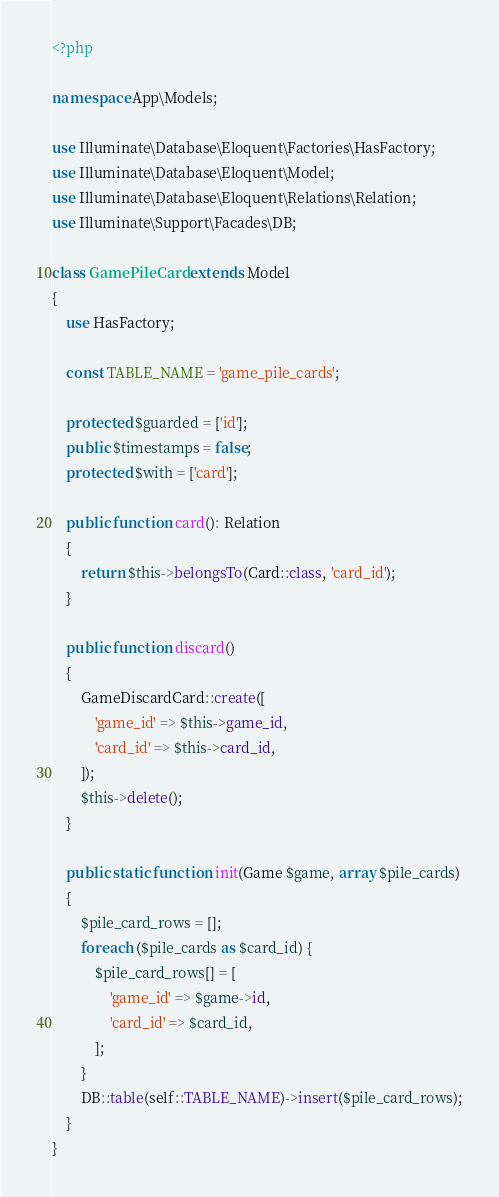Convert code to text. <code><loc_0><loc_0><loc_500><loc_500><_PHP_><?php

namespace App\Models;

use Illuminate\Database\Eloquent\Factories\HasFactory;
use Illuminate\Database\Eloquent\Model;
use Illuminate\Database\Eloquent\Relations\Relation;
use Illuminate\Support\Facades\DB;

class GamePileCard extends Model
{
    use HasFactory;

    const TABLE_NAME = 'game_pile_cards';

    protected $guarded = ['id'];
    public $timestamps = false;
    protected $with = ['card'];

    public function card(): Relation
    {
        return $this->belongsTo(Card::class, 'card_id');
    }

    public function discard()
    {
        GameDiscardCard::create([
            'game_id' => $this->game_id,
            'card_id' => $this->card_id,
        ]);
        $this->delete();
    }

    public static function init(Game $game, array $pile_cards)
    {
        $pile_card_rows = [];
        foreach ($pile_cards as $card_id) {
            $pile_card_rows[] = [
                'game_id' => $game->id,
                'card_id' => $card_id,
            ];
        }
        DB::table(self::TABLE_NAME)->insert($pile_card_rows);
    }
}
</code> 